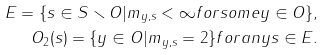<formula> <loc_0><loc_0><loc_500><loc_500>E = \{ s \in S \smallsetminus O | m _ { y , s } < \infty f o r s o m e y \in O \} , \\ O _ { 2 } ( s ) = \{ y \in O | m _ { y , s } = 2 \} f o r a n y s \in E .</formula> 